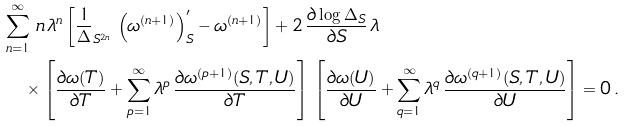Convert formula to latex. <formula><loc_0><loc_0><loc_500><loc_500>& \sum _ { n = 1 } ^ { \infty } \, n \, \lambda ^ { n } \left [ \frac { 1 } \Delta _ { S ^ { 2 n } } \, \left ( \omega ^ { ( n + 1 ) } \right ) ^ { \prime } _ { S } - \omega ^ { ( n + 1 ) } \right ] + 2 \, \frac { \partial \log \Delta _ { S } } { \partial S } \, \lambda \\ & \quad \times \left [ \frac { \partial \omega ( T ) } { \partial T } + \sum _ { p = 1 } ^ { \infty } \lambda ^ { p } \, \frac { \partial \omega ^ { ( p + 1 ) } ( S , T , U ) } { \partial T } \right ] \, \left [ \frac { \partial \omega ( U ) } { \partial U } + \sum _ { q = 1 } ^ { \infty } \lambda ^ { q } \, \frac { \partial \omega ^ { ( q + 1 ) } ( S , T , U ) } { \partial U } \right ] = 0 \, .</formula> 